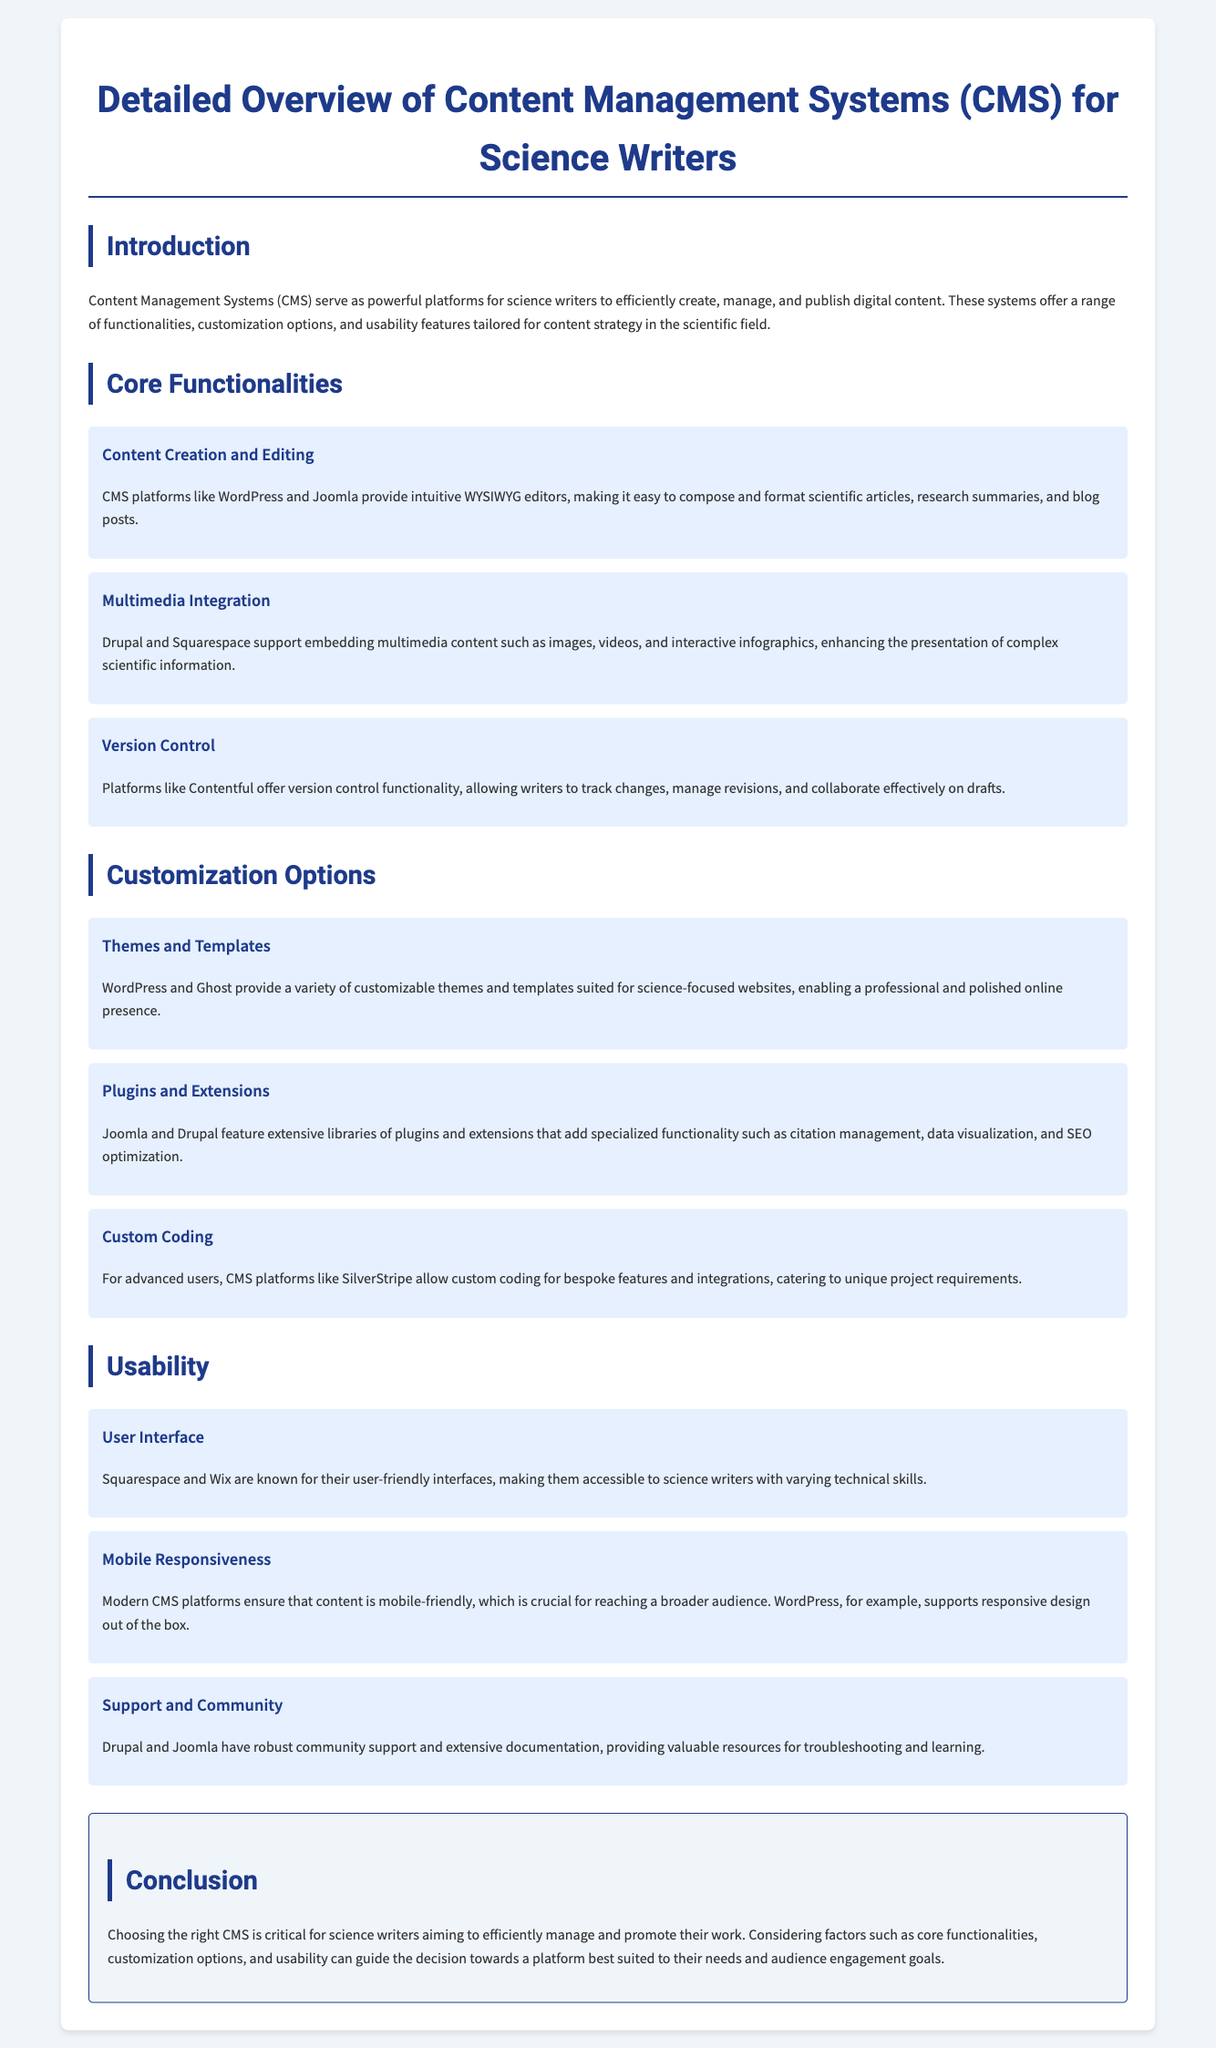what is the title of the document? The title is specified in the header section as "Detailed Overview of Content Management Systems (CMS) for Science Writers."
Answer: Detailed Overview of Content Management Systems (CMS) for Science Writers what are two examples of CMS platforms mentioned in the document? The document lists WordPress and Joomla as examples of CMS platforms.
Answer: WordPress and Joomla which functionality allows writers to track changes and manage revisions? The document states that version control functionality allows this, specifically mentioned in relation to Contentful.
Answer: Version control name one customization option available for CMS platforms. The document mentions themes and templates as one of the customization options.
Answer: Themes and templates which CMS platform is noted for its user-friendly interface? The document states that Squarespace is known for its user-friendly interface aimed at accessibility.
Answer: Squarespace what is a crucial feature that modern CMS platforms provide for audience reach? The document highlights mobile responsiveness as a critical feature for reaching a broader audience.
Answer: Mobile responsiveness which CMS platform supports responsive design out of the box? The document specifically mentions WordPress as supporting responsive design.
Answer: WordPress what type of support do Drupal and Joomla offer? The document states that they provide robust community support and extensive documentation.
Answer: Community support which aspect is emphasized as critical in choosing the right CMS for science writers? The document emphasizes considering core functionalities, customization options, and usability as critical factors in this choice.
Answer: Core functionalities, customization options, and usability 